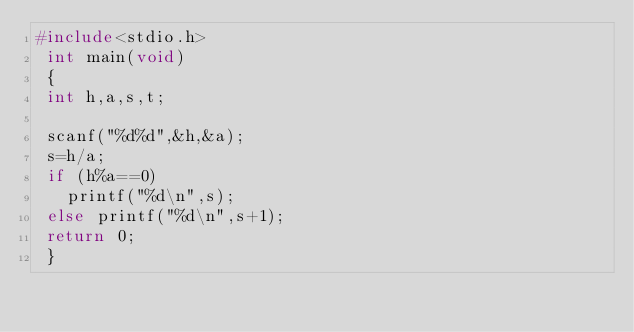Convert code to text. <code><loc_0><loc_0><loc_500><loc_500><_C_>#include<stdio.h>
 int main(void)
 {
 int h,a,s,t;

 scanf("%d%d",&h,&a);
 s=h/a;
 if (h%a==0)
   printf("%d\n",s);
 else printf("%d\n",s+1);
 return 0;
 }

</code> 